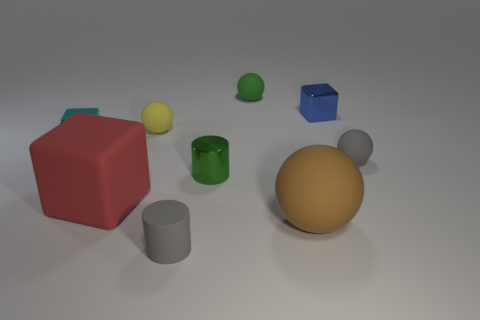What textures are visible in this image? The objects displayed have a variety of textures. The large brown ball has a rubber-like texture, presenting a matte finish. Meanwhile, the gray cylinder and the yellow sphere have smoother surfaces, indicating a possibly metallic or plastic material. The red cube and green objects seem to have a solid, non-reflective texture that might be indicative of a matte paint. 